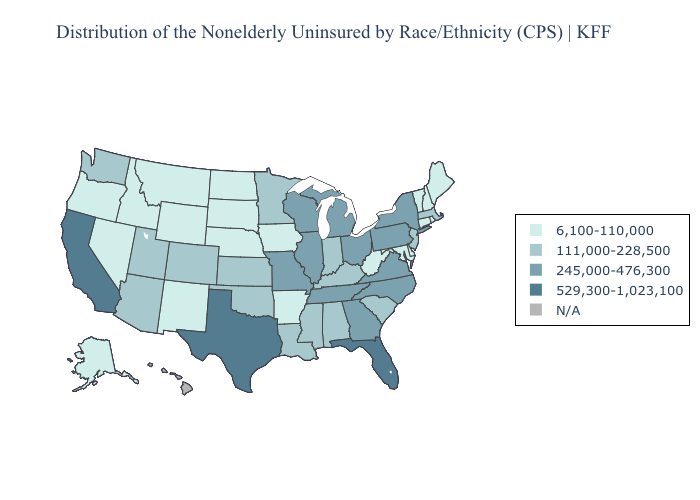What is the lowest value in the Northeast?
Keep it brief. 6,100-110,000. Name the states that have a value in the range 245,000-476,300?
Concise answer only. Georgia, Illinois, Michigan, Missouri, New York, North Carolina, Ohio, Pennsylvania, Tennessee, Virginia, Wisconsin. Among the states that border South Dakota , does Minnesota have the lowest value?
Keep it brief. No. Among the states that border Wisconsin , does Minnesota have the lowest value?
Quick response, please. No. What is the value of Indiana?
Write a very short answer. 111,000-228,500. Does Florida have the highest value in the USA?
Give a very brief answer. Yes. Name the states that have a value in the range 529,300-1,023,100?
Short answer required. California, Florida, Texas. Name the states that have a value in the range 111,000-228,500?
Be succinct. Alabama, Arizona, Colorado, Indiana, Kansas, Kentucky, Louisiana, Massachusetts, Minnesota, Mississippi, New Jersey, Oklahoma, South Carolina, Utah, Washington. What is the highest value in the South ?
Be succinct. 529,300-1,023,100. Name the states that have a value in the range 245,000-476,300?
Answer briefly. Georgia, Illinois, Michigan, Missouri, New York, North Carolina, Ohio, Pennsylvania, Tennessee, Virginia, Wisconsin. What is the value of Oklahoma?
Answer briefly. 111,000-228,500. What is the highest value in states that border Kansas?
Quick response, please. 245,000-476,300. What is the highest value in states that border Arkansas?
Quick response, please. 529,300-1,023,100. What is the lowest value in the USA?
Quick response, please. 6,100-110,000. Does Texas have the highest value in the USA?
Keep it brief. Yes. 